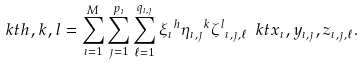<formula> <loc_0><loc_0><loc_500><loc_500>\ k t { h , k , l } = \sum _ { \imath = 1 } ^ { M } \sum _ { \jmath = 1 } ^ { p _ { \imath } } \sum _ { \ell = 1 } ^ { q _ { \imath , \jmath } } { \xi _ { \imath } } ^ { h } { \eta _ { \imath , \jmath } } ^ { k } { \zeta ^ { l } } _ { \imath , \jmath , \ell } \ k t { x _ { \imath } , y _ { \imath , \jmath } , z _ { \imath , \jmath , \ell } } .</formula> 